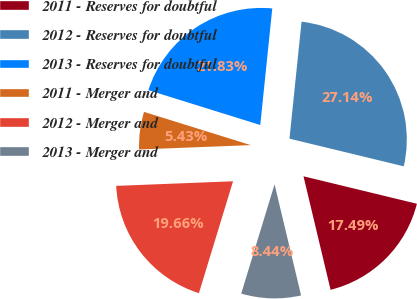Convert chart to OTSL. <chart><loc_0><loc_0><loc_500><loc_500><pie_chart><fcel>2011 - Reserves for doubtful<fcel>2012 - Reserves for doubtful<fcel>2013 - Reserves for doubtful<fcel>2011 - Merger and<fcel>2012 - Merger and<fcel>2013 - Merger and<nl><fcel>17.49%<fcel>27.14%<fcel>21.83%<fcel>5.43%<fcel>19.66%<fcel>8.44%<nl></chart> 